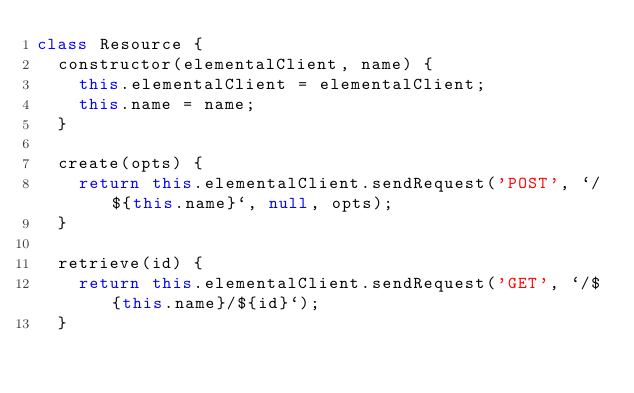<code> <loc_0><loc_0><loc_500><loc_500><_JavaScript_>class Resource {
  constructor(elementalClient, name) {
    this.elementalClient = elementalClient;
    this.name = name;
  }

  create(opts) {
    return this.elementalClient.sendRequest('POST', `/${this.name}`, null, opts);
  }

  retrieve(id) {
    return this.elementalClient.sendRequest('GET', `/${this.name}/${id}`);
  }
</code> 